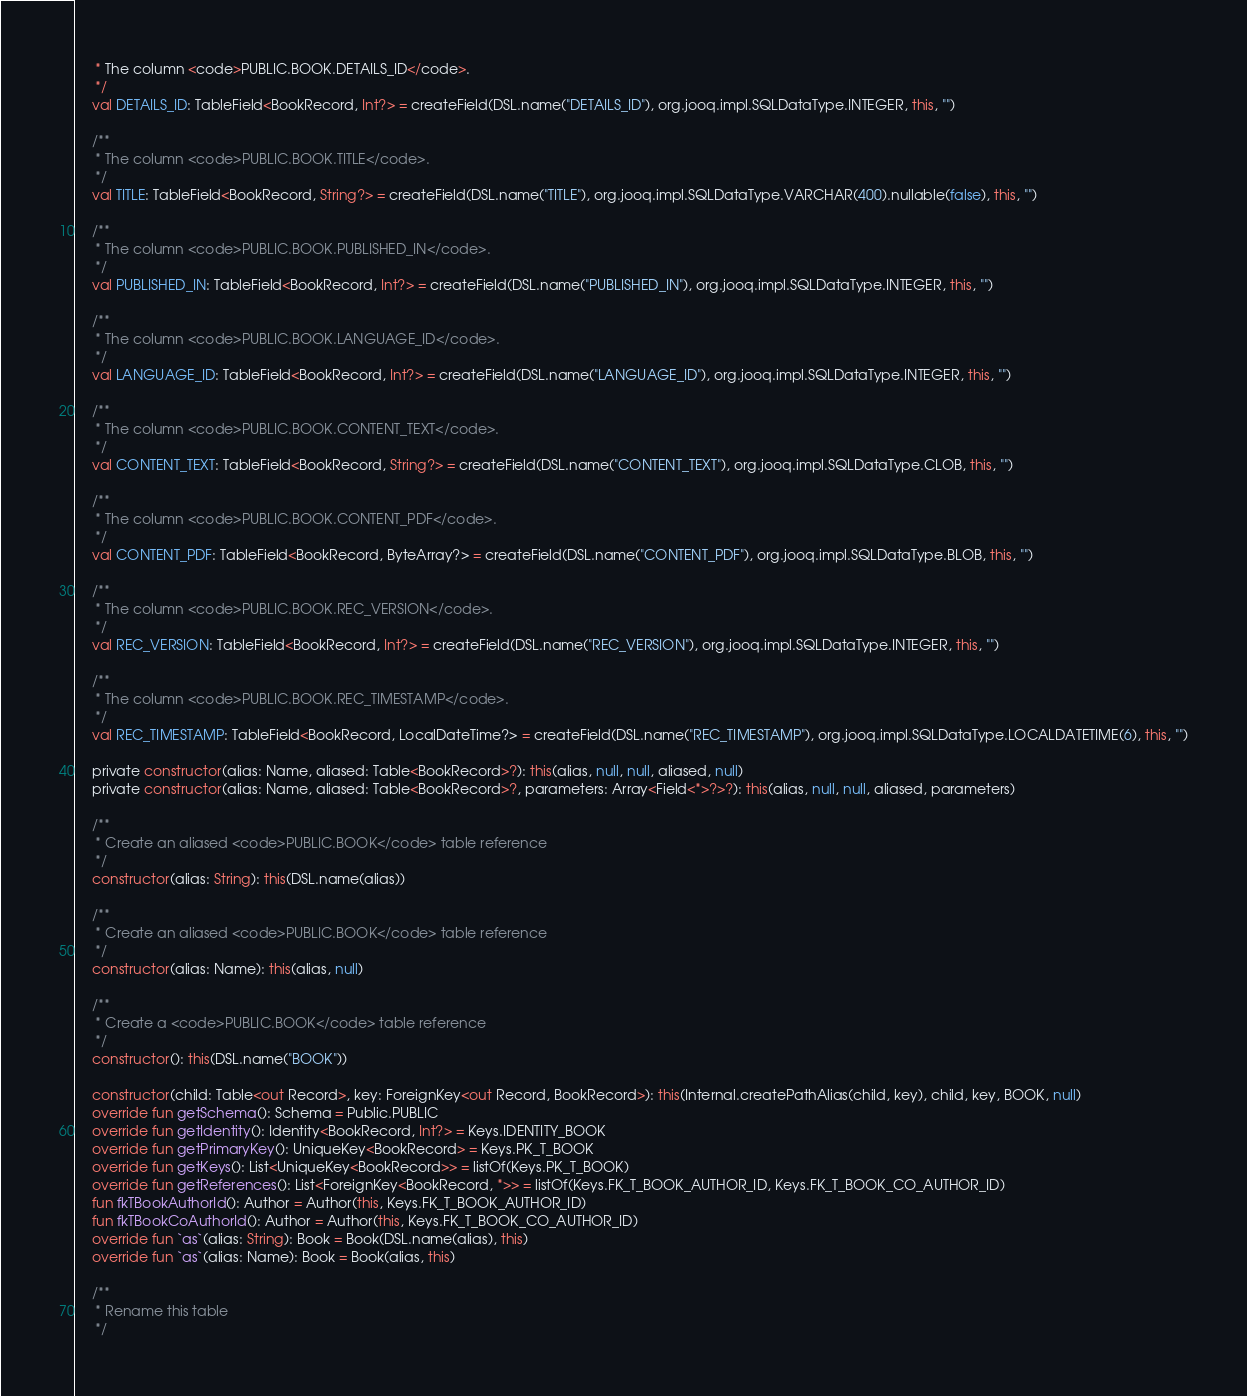<code> <loc_0><loc_0><loc_500><loc_500><_Kotlin_>     * The column <code>PUBLIC.BOOK.DETAILS_ID</code>.
     */
    val DETAILS_ID: TableField<BookRecord, Int?> = createField(DSL.name("DETAILS_ID"), org.jooq.impl.SQLDataType.INTEGER, this, "")

    /**
     * The column <code>PUBLIC.BOOK.TITLE</code>.
     */
    val TITLE: TableField<BookRecord, String?> = createField(DSL.name("TITLE"), org.jooq.impl.SQLDataType.VARCHAR(400).nullable(false), this, "")

    /**
     * The column <code>PUBLIC.BOOK.PUBLISHED_IN</code>.
     */
    val PUBLISHED_IN: TableField<BookRecord, Int?> = createField(DSL.name("PUBLISHED_IN"), org.jooq.impl.SQLDataType.INTEGER, this, "")

    /**
     * The column <code>PUBLIC.BOOK.LANGUAGE_ID</code>.
     */
    val LANGUAGE_ID: TableField<BookRecord, Int?> = createField(DSL.name("LANGUAGE_ID"), org.jooq.impl.SQLDataType.INTEGER, this, "")

    /**
     * The column <code>PUBLIC.BOOK.CONTENT_TEXT</code>.
     */
    val CONTENT_TEXT: TableField<BookRecord, String?> = createField(DSL.name("CONTENT_TEXT"), org.jooq.impl.SQLDataType.CLOB, this, "")

    /**
     * The column <code>PUBLIC.BOOK.CONTENT_PDF</code>.
     */
    val CONTENT_PDF: TableField<BookRecord, ByteArray?> = createField(DSL.name("CONTENT_PDF"), org.jooq.impl.SQLDataType.BLOB, this, "")

    /**
     * The column <code>PUBLIC.BOOK.REC_VERSION</code>.
     */
    val REC_VERSION: TableField<BookRecord, Int?> = createField(DSL.name("REC_VERSION"), org.jooq.impl.SQLDataType.INTEGER, this, "")

    /**
     * The column <code>PUBLIC.BOOK.REC_TIMESTAMP</code>.
     */
    val REC_TIMESTAMP: TableField<BookRecord, LocalDateTime?> = createField(DSL.name("REC_TIMESTAMP"), org.jooq.impl.SQLDataType.LOCALDATETIME(6), this, "")

    private constructor(alias: Name, aliased: Table<BookRecord>?): this(alias, null, null, aliased, null)
    private constructor(alias: Name, aliased: Table<BookRecord>?, parameters: Array<Field<*>?>?): this(alias, null, null, aliased, parameters)

    /**
     * Create an aliased <code>PUBLIC.BOOK</code> table reference
     */
    constructor(alias: String): this(DSL.name(alias))

    /**
     * Create an aliased <code>PUBLIC.BOOK</code> table reference
     */
    constructor(alias: Name): this(alias, null)

    /**
     * Create a <code>PUBLIC.BOOK</code> table reference
     */
    constructor(): this(DSL.name("BOOK"))

    constructor(child: Table<out Record>, key: ForeignKey<out Record, BookRecord>): this(Internal.createPathAlias(child, key), child, key, BOOK, null)
    override fun getSchema(): Schema = Public.PUBLIC
    override fun getIdentity(): Identity<BookRecord, Int?> = Keys.IDENTITY_BOOK
    override fun getPrimaryKey(): UniqueKey<BookRecord> = Keys.PK_T_BOOK
    override fun getKeys(): List<UniqueKey<BookRecord>> = listOf(Keys.PK_T_BOOK)
    override fun getReferences(): List<ForeignKey<BookRecord, *>> = listOf(Keys.FK_T_BOOK_AUTHOR_ID, Keys.FK_T_BOOK_CO_AUTHOR_ID)
    fun fkTBookAuthorId(): Author = Author(this, Keys.FK_T_BOOK_AUTHOR_ID)
    fun fkTBookCoAuthorId(): Author = Author(this, Keys.FK_T_BOOK_CO_AUTHOR_ID)
    override fun `as`(alias: String): Book = Book(DSL.name(alias), this)
    override fun `as`(alias: Name): Book = Book(alias, this)

    /**
     * Rename this table
     */</code> 